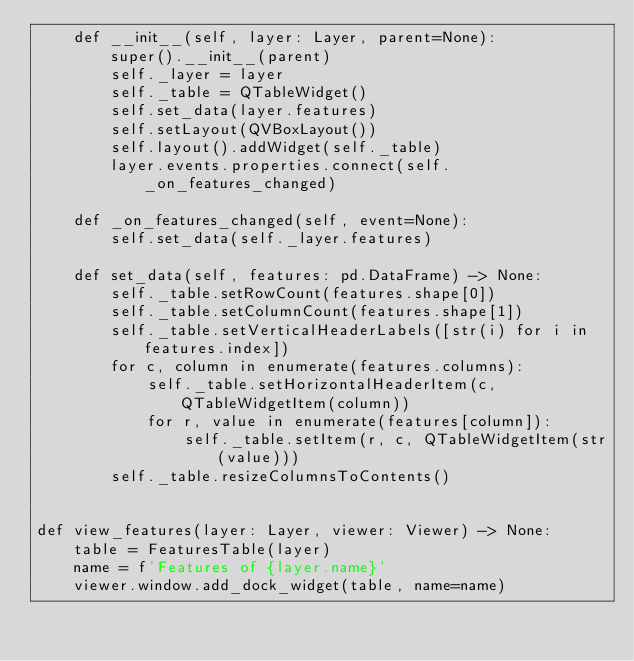Convert code to text. <code><loc_0><loc_0><loc_500><loc_500><_Python_>    def __init__(self, layer: Layer, parent=None):
        super().__init__(parent)
        self._layer = layer
        self._table = QTableWidget()
        self.set_data(layer.features)
        self.setLayout(QVBoxLayout())
        self.layout().addWidget(self._table)
        layer.events.properties.connect(self._on_features_changed)

    def _on_features_changed(self, event=None):
        self.set_data(self._layer.features)

    def set_data(self, features: pd.DataFrame) -> None:
        self._table.setRowCount(features.shape[0])
        self._table.setColumnCount(features.shape[1])
        self._table.setVerticalHeaderLabels([str(i) for i in features.index])
        for c, column in enumerate(features.columns):
            self._table.setHorizontalHeaderItem(c, QTableWidgetItem(column))
            for r, value in enumerate(features[column]):
                self._table.setItem(r, c, QTableWidgetItem(str(value)))
        self._table.resizeColumnsToContents()


def view_features(layer: Layer, viewer: Viewer) -> None:
    table = FeaturesTable(layer)
    name = f'Features of {layer.name}'
    viewer.window.add_dock_widget(table, name=name)

</code> 